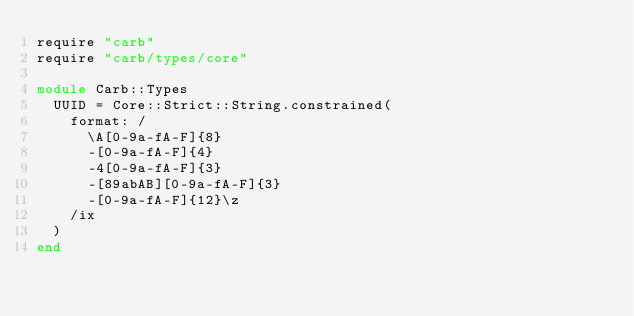Convert code to text. <code><loc_0><loc_0><loc_500><loc_500><_Ruby_>require "carb"
require "carb/types/core"

module Carb::Types
  UUID = Core::Strict::String.constrained(
    format: /
      \A[0-9a-fA-F]{8}
      -[0-9a-fA-F]{4}
      -4[0-9a-fA-F]{3}
      -[89abAB][0-9a-fA-F]{3}
      -[0-9a-fA-F]{12}\z
    /ix
  )
end
</code> 